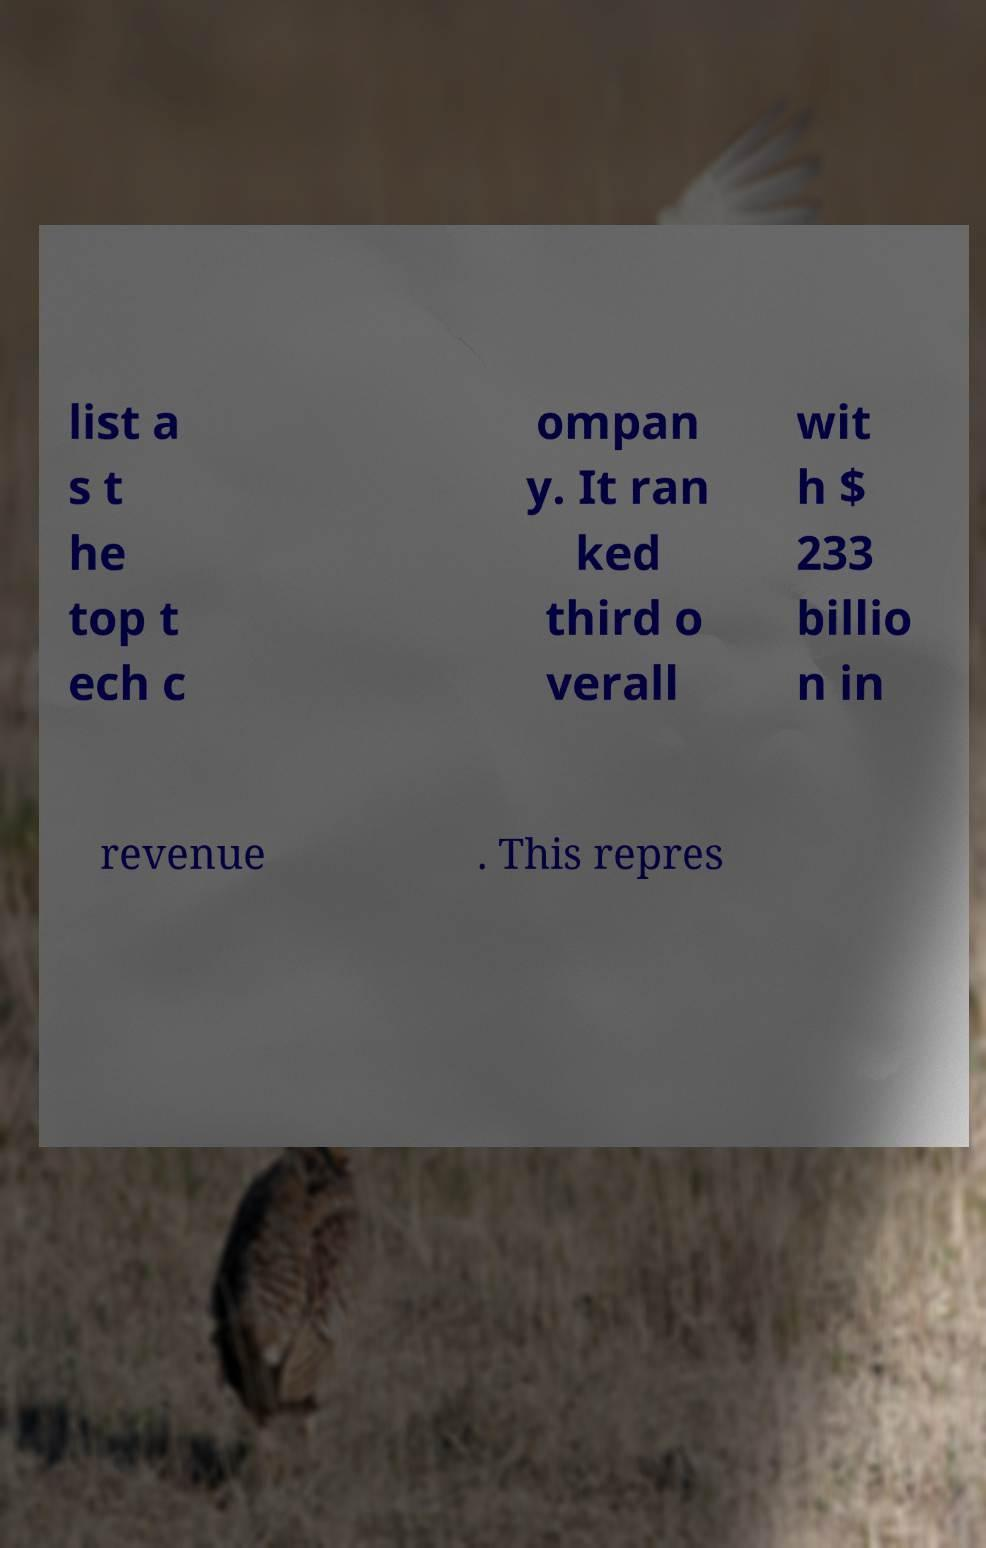For documentation purposes, I need the text within this image transcribed. Could you provide that? list a s t he top t ech c ompan y. It ran ked third o verall wit h $ 233 billio n in revenue . This repres 